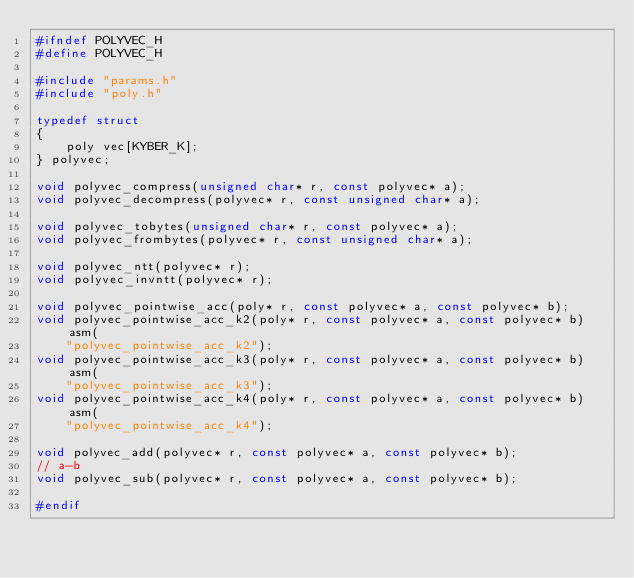<code> <loc_0><loc_0><loc_500><loc_500><_C_>#ifndef POLYVEC_H
#define POLYVEC_H

#include "params.h"
#include "poly.h"

typedef struct
{
    poly vec[KYBER_K];
} polyvec;

void polyvec_compress(unsigned char* r, const polyvec* a);
void polyvec_decompress(polyvec* r, const unsigned char* a);

void polyvec_tobytes(unsigned char* r, const polyvec* a);
void polyvec_frombytes(polyvec* r, const unsigned char* a);

void polyvec_ntt(polyvec* r);
void polyvec_invntt(polyvec* r);

void polyvec_pointwise_acc(poly* r, const polyvec* a, const polyvec* b);
void polyvec_pointwise_acc_k2(poly* r, const polyvec* a, const polyvec* b) asm(
    "polyvec_pointwise_acc_k2");
void polyvec_pointwise_acc_k3(poly* r, const polyvec* a, const polyvec* b) asm(
    "polyvec_pointwise_acc_k3");
void polyvec_pointwise_acc_k4(poly* r, const polyvec* a, const polyvec* b) asm(
    "polyvec_pointwise_acc_k4");

void polyvec_add(polyvec* r, const polyvec* a, const polyvec* b);
// a-b
void polyvec_sub(polyvec* r, const polyvec* a, const polyvec* b);

#endif
</code> 